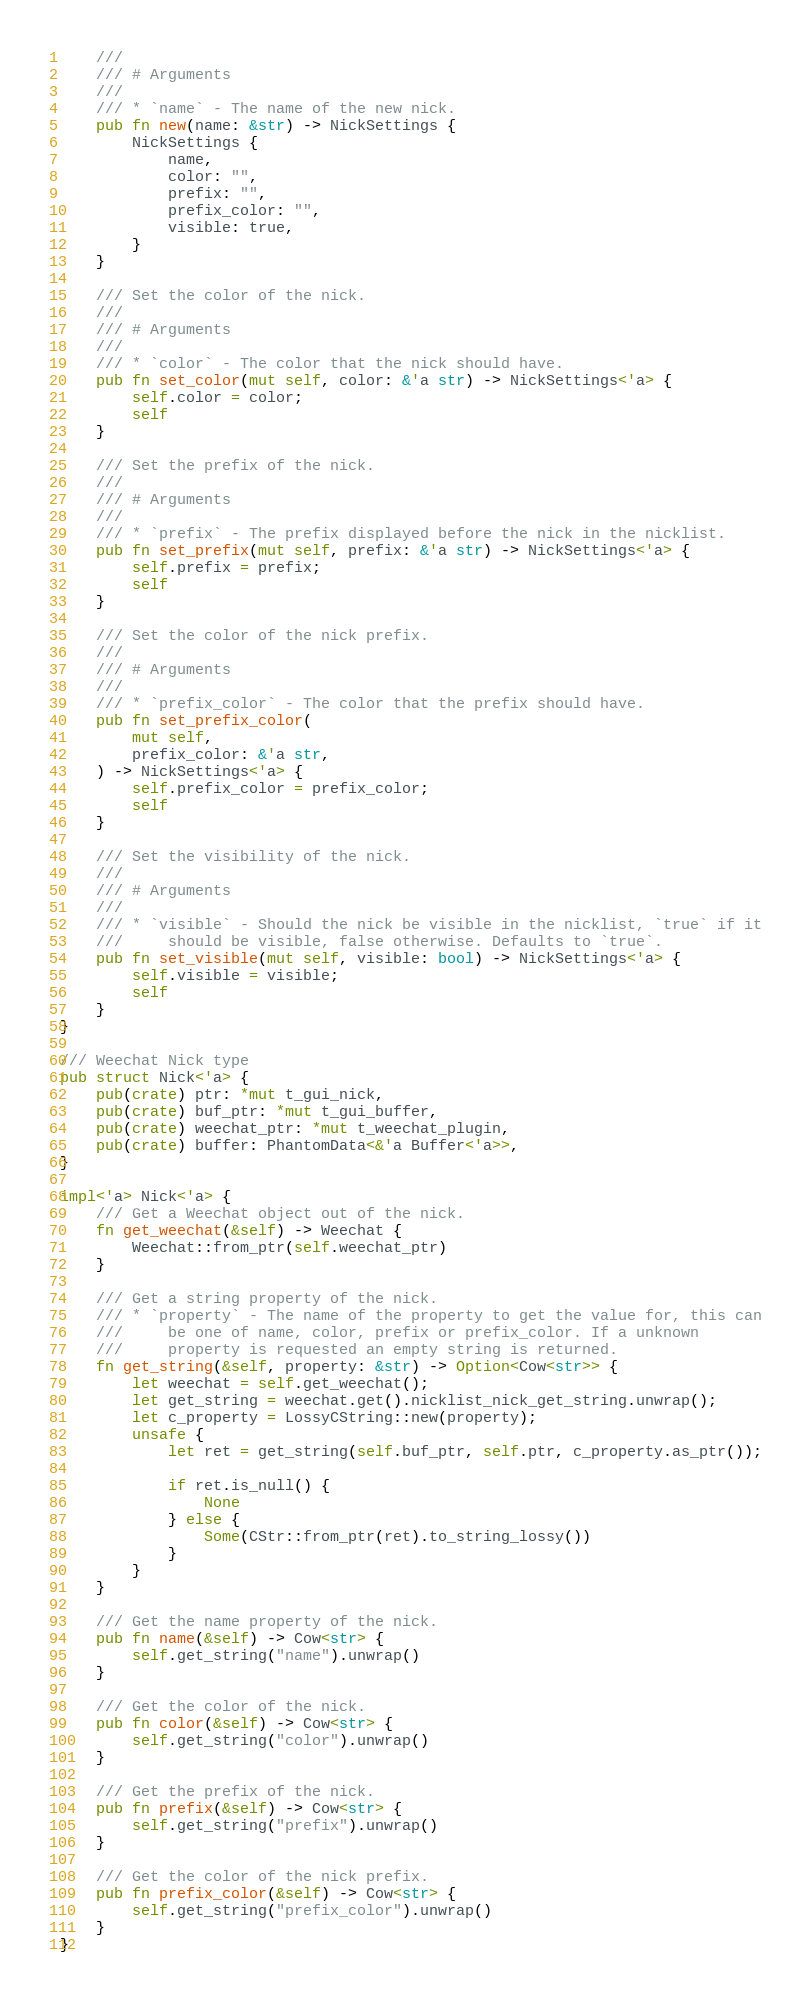Convert code to text. <code><loc_0><loc_0><loc_500><loc_500><_Rust_>    ///
    /// # Arguments
    ///
    /// * `name` - The name of the new nick.
    pub fn new(name: &str) -> NickSettings {
        NickSettings {
            name,
            color: "",
            prefix: "",
            prefix_color: "",
            visible: true,
        }
    }

    /// Set the color of the nick.
    ///
    /// # Arguments
    ///
    /// * `color` - The color that the nick should have.
    pub fn set_color(mut self, color: &'a str) -> NickSettings<'a> {
        self.color = color;
        self
    }

    /// Set the prefix of the nick.
    ///
    /// # Arguments
    ///
    /// * `prefix` - The prefix displayed before the nick in the nicklist.
    pub fn set_prefix(mut self, prefix: &'a str) -> NickSettings<'a> {
        self.prefix = prefix;
        self
    }

    /// Set the color of the nick prefix.
    ///
    /// # Arguments
    ///
    /// * `prefix_color` - The color that the prefix should have.
    pub fn set_prefix_color(
        mut self,
        prefix_color: &'a str,
    ) -> NickSettings<'a> {
        self.prefix_color = prefix_color;
        self
    }

    /// Set the visibility of the nick.
    ///
    /// # Arguments
    ///
    /// * `visible` - Should the nick be visible in the nicklist, `true` if it
    ///     should be visible, false otherwise. Defaults to `true`.
    pub fn set_visible(mut self, visible: bool) -> NickSettings<'a> {
        self.visible = visible;
        self
    }
}

/// Weechat Nick type
pub struct Nick<'a> {
    pub(crate) ptr: *mut t_gui_nick,
    pub(crate) buf_ptr: *mut t_gui_buffer,
    pub(crate) weechat_ptr: *mut t_weechat_plugin,
    pub(crate) buffer: PhantomData<&'a Buffer<'a>>,
}

impl<'a> Nick<'a> {
    /// Get a Weechat object out of the nick.
    fn get_weechat(&self) -> Weechat {
        Weechat::from_ptr(self.weechat_ptr)
    }

    /// Get a string property of the nick.
    /// * `property` - The name of the property to get the value for, this can
    ///     be one of name, color, prefix or prefix_color. If a unknown
    ///     property is requested an empty string is returned.
    fn get_string(&self, property: &str) -> Option<Cow<str>> {
        let weechat = self.get_weechat();
        let get_string = weechat.get().nicklist_nick_get_string.unwrap();
        let c_property = LossyCString::new(property);
        unsafe {
            let ret = get_string(self.buf_ptr, self.ptr, c_property.as_ptr());

            if ret.is_null() {
                None
            } else {
                Some(CStr::from_ptr(ret).to_string_lossy())
            }
        }
    }

    /// Get the name property of the nick.
    pub fn name(&self) -> Cow<str> {
        self.get_string("name").unwrap()
    }

    /// Get the color of the nick.
    pub fn color(&self) -> Cow<str> {
        self.get_string("color").unwrap()
    }

    /// Get the prefix of the nick.
    pub fn prefix(&self) -> Cow<str> {
        self.get_string("prefix").unwrap()
    }

    /// Get the color of the nick prefix.
    pub fn prefix_color(&self) -> Cow<str> {
        self.get_string("prefix_color").unwrap()
    }
}
</code> 